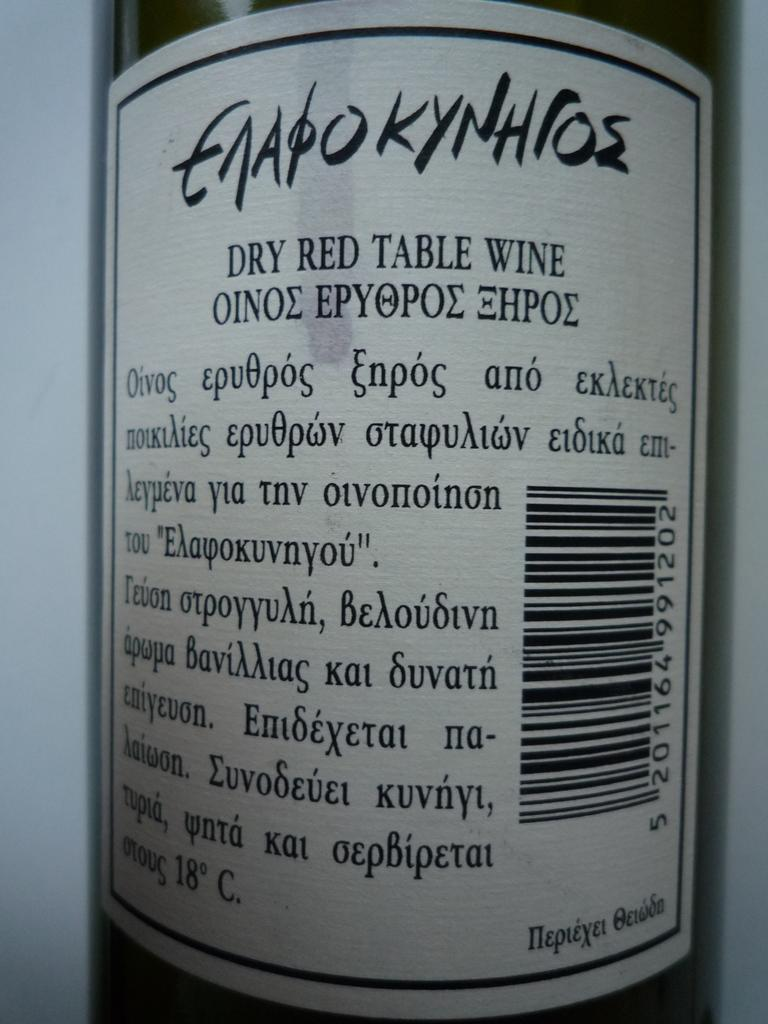Provide a one-sentence caption for the provided image. The back of a wine bottle written in a different language. 